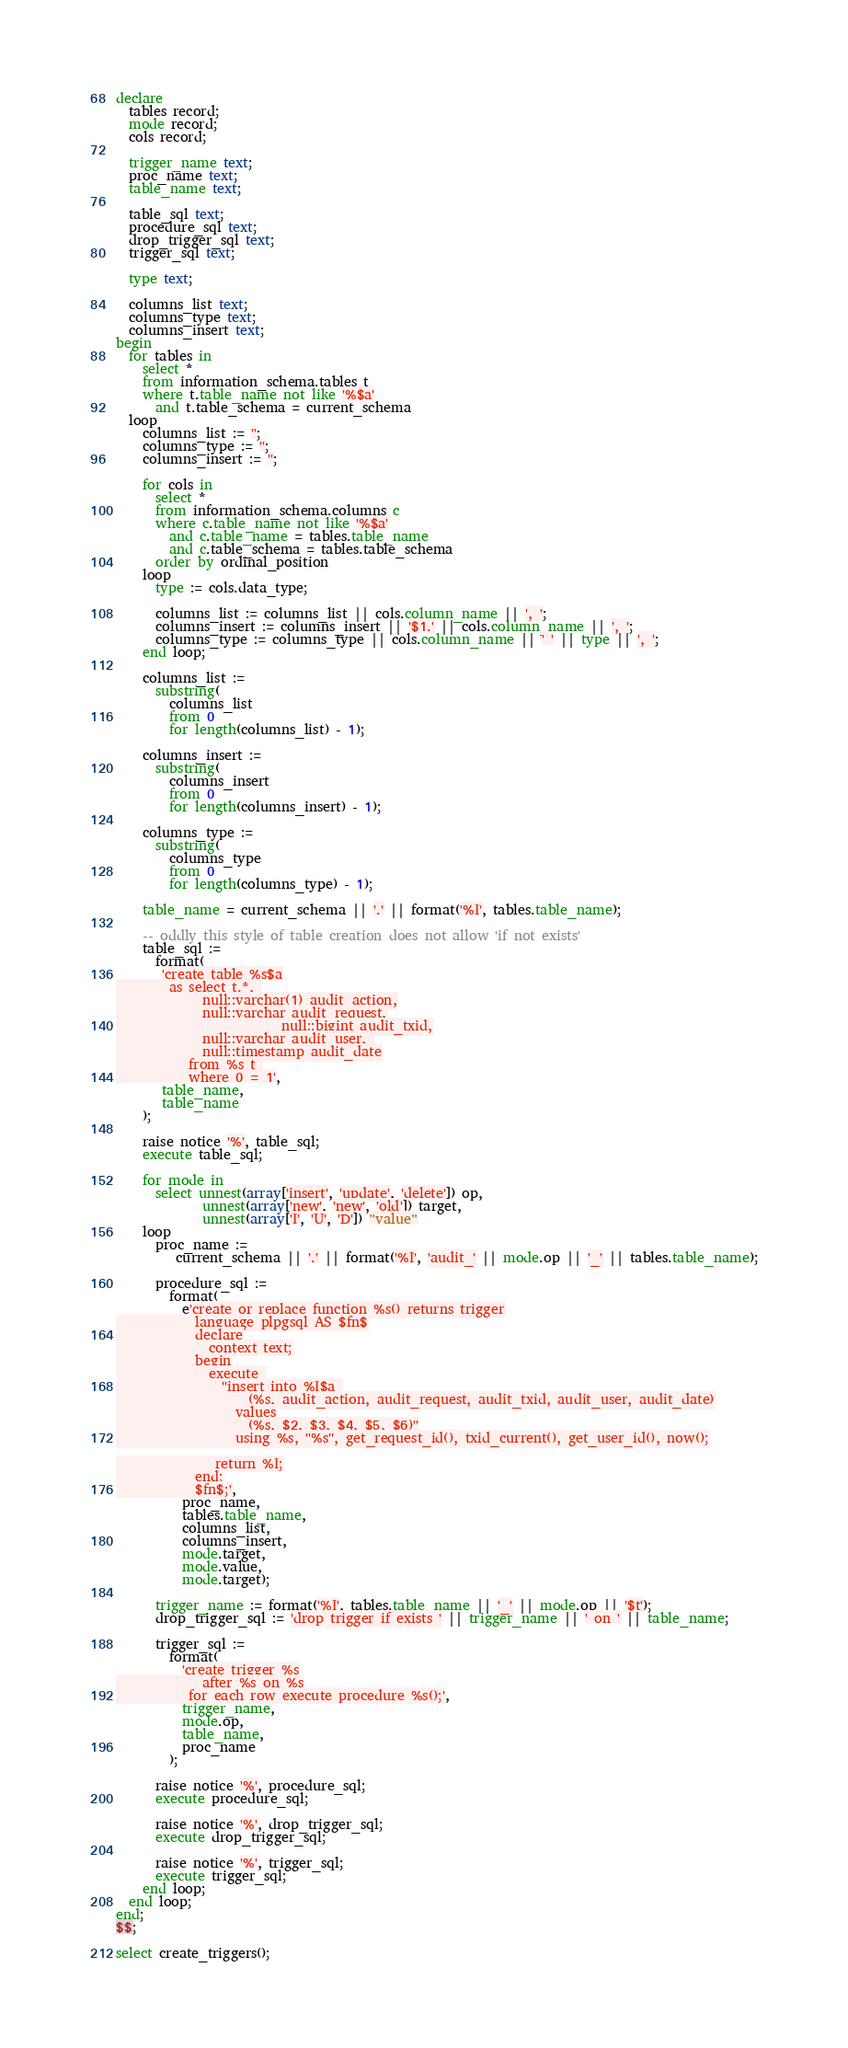<code> <loc_0><loc_0><loc_500><loc_500><_SQL_>declare
  tables record;
  mode record;
  cols record;

  trigger_name text;
  proc_name text;
  table_name text;

  table_sql text;
  procedure_sql text;
  drop_trigger_sql text;
  trigger_sql text;

  type text;

  columns_list text;
  columns_type text;
  columns_insert text;
begin
  for tables in 
    select * 
    from information_schema.tables t
    where t.table_name not like '%$a' 
      and t.table_schema = current_schema
  loop
    columns_list := '';
    columns_type := '';
    columns_insert := '';  
  
    for cols in
      select * 
      from information_schema.columns c
      where c.table_name not like '%$a'
        and c.table_name = tables.table_name
        and c.table_schema = tables.table_schema
      order by ordinal_position
    loop     
      type := cols.data_type;   
      
      columns_list := columns_list || cols.column_name || ', ';
      columns_insert := columns_insert || '$1.' || cols.column_name || ', ';
      columns_type := columns_type || cols.column_name || ' ' || type || ', ';
    end loop;

    columns_list := 
      substring(
        columns_list 
        from 0 
        for length(columns_list) - 1);

    columns_insert := 
      substring(
        columns_insert 
        from 0 
        for length(columns_insert) - 1);
        
    columns_type := 
      substring(
        columns_type 
        from 0 
        for length(columns_type) - 1);

    table_name = current_schema || '.' || format('%I', tables.table_name);

    -- oddly this style of table creation does not allow 'if not exists'
    table_sql := 
      format(
       'create table %s$a
        as select t.*, 
             null::varchar(1) audit_action,
             null::varchar audit_request,
						 null::bigint audit_txid,
             null::varchar audit_user, 
             null::timestamp audit_date
           from %s t 
           where 0 = 1',
       table_name,
       table_name
    );
 
    raise notice '%', table_sql;
    execute table_sql;

    for mode in 
      select unnest(array['insert', 'update', 'delete']) op,
             unnest(array['new', 'new', 'old']) target,
             unnest(array['I', 'U', 'D']) "value"
    loop
      proc_name :=
         current_schema || '.' || format('%I', 'audit_' || mode.op || '_' || tables.table_name);

      procedure_sql := 
        format(
          e'create or replace function %s() returns trigger
            language plpgsql AS $fn$
            declare
              context text;
            begin
              execute 
                ''insert into %I$a 
                    (%s, audit_action, audit_request, audit_txid, audit_user, audit_date)
                  values
                    (%s, $2, $3, $4, $5, $6)''
                  using %s, ''%s'', get_request_id(), txid_current(), get_user_id(), now();

               return %I;
            end;
            $fn$;',
          proc_name,
          tables.table_name,
          columns_list,
          columns_insert,
          mode.target,
          mode.value,
          mode.target);

      trigger_name := format('%I', tables.table_name || '_' || mode.op || '$t');
      drop_trigger_sql := 'drop trigger if exists ' || trigger_name || ' on ' || table_name;
    
      trigger_sql :=
        format(
          'create trigger %s
             after %s on %s
           for each row execute procedure %s();',
          trigger_name,
          mode.op,
          table_name,
          proc_name
        );

      raise notice '%', procedure_sql;
      execute procedure_sql;

      raise notice '%', drop_trigger_sql;
      execute drop_trigger_sql;
        
      raise notice '%', trigger_sql;    
      execute trigger_sql;
    end loop;
  end loop;
end;
$$;

select create_triggers();
</code> 